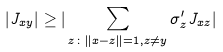<formula> <loc_0><loc_0><loc_500><loc_500>| J _ { x y } | \geq | \sum _ { z \colon \| x - z \| = 1 , z \ne y } \sigma ^ { \prime } _ { z } J _ { x z } |</formula> 